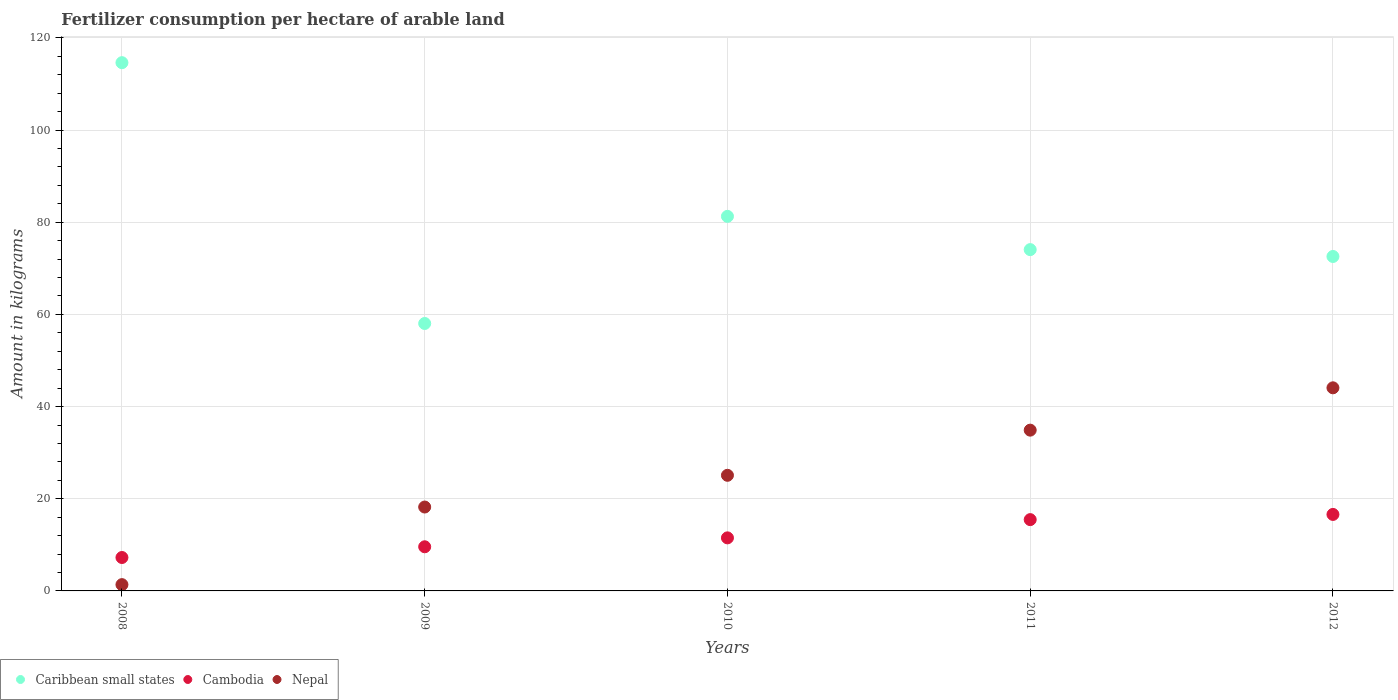What is the amount of fertilizer consumption in Cambodia in 2008?
Keep it short and to the point. 7.25. Across all years, what is the maximum amount of fertilizer consumption in Caribbean small states?
Your answer should be very brief. 114.62. Across all years, what is the minimum amount of fertilizer consumption in Cambodia?
Offer a terse response. 7.25. In which year was the amount of fertilizer consumption in Caribbean small states maximum?
Offer a very short reply. 2008. What is the total amount of fertilizer consumption in Caribbean small states in the graph?
Offer a very short reply. 400.54. What is the difference between the amount of fertilizer consumption in Cambodia in 2009 and that in 2011?
Offer a very short reply. -5.89. What is the difference between the amount of fertilizer consumption in Nepal in 2010 and the amount of fertilizer consumption in Caribbean small states in 2008?
Ensure brevity in your answer.  -89.53. What is the average amount of fertilizer consumption in Nepal per year?
Offer a terse response. 24.72. In the year 2010, what is the difference between the amount of fertilizer consumption in Cambodia and amount of fertilizer consumption in Caribbean small states?
Provide a short and direct response. -69.76. What is the ratio of the amount of fertilizer consumption in Nepal in 2009 to that in 2010?
Keep it short and to the point. 0.73. Is the amount of fertilizer consumption in Cambodia in 2010 less than that in 2012?
Offer a very short reply. Yes. Is the difference between the amount of fertilizer consumption in Cambodia in 2008 and 2009 greater than the difference between the amount of fertilizer consumption in Caribbean small states in 2008 and 2009?
Keep it short and to the point. No. What is the difference between the highest and the second highest amount of fertilizer consumption in Caribbean small states?
Offer a very short reply. 33.34. What is the difference between the highest and the lowest amount of fertilizer consumption in Cambodia?
Offer a very short reply. 9.35. In how many years, is the amount of fertilizer consumption in Caribbean small states greater than the average amount of fertilizer consumption in Caribbean small states taken over all years?
Your answer should be very brief. 2. Is the sum of the amount of fertilizer consumption in Nepal in 2009 and 2010 greater than the maximum amount of fertilizer consumption in Caribbean small states across all years?
Your response must be concise. No. Does the amount of fertilizer consumption in Cambodia monotonically increase over the years?
Keep it short and to the point. Yes. Is the amount of fertilizer consumption in Nepal strictly less than the amount of fertilizer consumption in Cambodia over the years?
Provide a short and direct response. No. How many dotlines are there?
Your answer should be very brief. 3. How many years are there in the graph?
Provide a short and direct response. 5. Are the values on the major ticks of Y-axis written in scientific E-notation?
Keep it short and to the point. No. How are the legend labels stacked?
Offer a very short reply. Horizontal. What is the title of the graph?
Offer a very short reply. Fertilizer consumption per hectare of arable land. What is the label or title of the Y-axis?
Your answer should be very brief. Amount in kilograms. What is the Amount in kilograms in Caribbean small states in 2008?
Keep it short and to the point. 114.62. What is the Amount in kilograms in Cambodia in 2008?
Give a very brief answer. 7.25. What is the Amount in kilograms of Nepal in 2008?
Provide a short and direct response. 1.36. What is the Amount in kilograms of Caribbean small states in 2009?
Your answer should be very brief. 58.03. What is the Amount in kilograms in Cambodia in 2009?
Keep it short and to the point. 9.58. What is the Amount in kilograms in Nepal in 2009?
Provide a succinct answer. 18.2. What is the Amount in kilograms of Caribbean small states in 2010?
Provide a short and direct response. 81.27. What is the Amount in kilograms of Cambodia in 2010?
Make the answer very short. 11.51. What is the Amount in kilograms in Nepal in 2010?
Make the answer very short. 25.09. What is the Amount in kilograms in Caribbean small states in 2011?
Keep it short and to the point. 74.06. What is the Amount in kilograms of Cambodia in 2011?
Your answer should be compact. 15.47. What is the Amount in kilograms of Nepal in 2011?
Ensure brevity in your answer.  34.88. What is the Amount in kilograms in Caribbean small states in 2012?
Keep it short and to the point. 72.57. What is the Amount in kilograms of Cambodia in 2012?
Your response must be concise. 16.6. What is the Amount in kilograms in Nepal in 2012?
Your response must be concise. 44.07. Across all years, what is the maximum Amount in kilograms of Caribbean small states?
Give a very brief answer. 114.62. Across all years, what is the maximum Amount in kilograms in Cambodia?
Keep it short and to the point. 16.6. Across all years, what is the maximum Amount in kilograms in Nepal?
Your response must be concise. 44.07. Across all years, what is the minimum Amount in kilograms of Caribbean small states?
Your answer should be compact. 58.03. Across all years, what is the minimum Amount in kilograms in Cambodia?
Ensure brevity in your answer.  7.25. Across all years, what is the minimum Amount in kilograms of Nepal?
Offer a terse response. 1.36. What is the total Amount in kilograms of Caribbean small states in the graph?
Keep it short and to the point. 400.54. What is the total Amount in kilograms in Cambodia in the graph?
Ensure brevity in your answer.  60.41. What is the total Amount in kilograms of Nepal in the graph?
Make the answer very short. 123.61. What is the difference between the Amount in kilograms in Caribbean small states in 2008 and that in 2009?
Make the answer very short. 56.59. What is the difference between the Amount in kilograms of Cambodia in 2008 and that in 2009?
Make the answer very short. -2.33. What is the difference between the Amount in kilograms in Nepal in 2008 and that in 2009?
Your answer should be very brief. -16.84. What is the difference between the Amount in kilograms in Caribbean small states in 2008 and that in 2010?
Provide a succinct answer. 33.34. What is the difference between the Amount in kilograms of Cambodia in 2008 and that in 2010?
Your answer should be compact. -4.26. What is the difference between the Amount in kilograms in Nepal in 2008 and that in 2010?
Give a very brief answer. -23.72. What is the difference between the Amount in kilograms of Caribbean small states in 2008 and that in 2011?
Provide a succinct answer. 40.56. What is the difference between the Amount in kilograms in Cambodia in 2008 and that in 2011?
Give a very brief answer. -8.22. What is the difference between the Amount in kilograms of Nepal in 2008 and that in 2011?
Your answer should be compact. -33.52. What is the difference between the Amount in kilograms of Caribbean small states in 2008 and that in 2012?
Keep it short and to the point. 42.05. What is the difference between the Amount in kilograms of Cambodia in 2008 and that in 2012?
Offer a terse response. -9.35. What is the difference between the Amount in kilograms of Nepal in 2008 and that in 2012?
Your response must be concise. -42.7. What is the difference between the Amount in kilograms of Caribbean small states in 2009 and that in 2010?
Offer a very short reply. -23.25. What is the difference between the Amount in kilograms in Cambodia in 2009 and that in 2010?
Offer a very short reply. -1.93. What is the difference between the Amount in kilograms in Nepal in 2009 and that in 2010?
Provide a short and direct response. -6.88. What is the difference between the Amount in kilograms of Caribbean small states in 2009 and that in 2011?
Ensure brevity in your answer.  -16.03. What is the difference between the Amount in kilograms in Cambodia in 2009 and that in 2011?
Your response must be concise. -5.89. What is the difference between the Amount in kilograms of Nepal in 2009 and that in 2011?
Your answer should be very brief. -16.68. What is the difference between the Amount in kilograms of Caribbean small states in 2009 and that in 2012?
Your response must be concise. -14.54. What is the difference between the Amount in kilograms of Cambodia in 2009 and that in 2012?
Keep it short and to the point. -7.02. What is the difference between the Amount in kilograms in Nepal in 2009 and that in 2012?
Provide a short and direct response. -25.87. What is the difference between the Amount in kilograms in Caribbean small states in 2010 and that in 2011?
Give a very brief answer. 7.22. What is the difference between the Amount in kilograms in Cambodia in 2010 and that in 2011?
Make the answer very short. -3.96. What is the difference between the Amount in kilograms in Nepal in 2010 and that in 2011?
Your response must be concise. -9.8. What is the difference between the Amount in kilograms of Caribbean small states in 2010 and that in 2012?
Offer a very short reply. 8.71. What is the difference between the Amount in kilograms in Cambodia in 2010 and that in 2012?
Your response must be concise. -5.08. What is the difference between the Amount in kilograms in Nepal in 2010 and that in 2012?
Your answer should be compact. -18.98. What is the difference between the Amount in kilograms in Caribbean small states in 2011 and that in 2012?
Provide a succinct answer. 1.49. What is the difference between the Amount in kilograms of Cambodia in 2011 and that in 2012?
Make the answer very short. -1.13. What is the difference between the Amount in kilograms in Nepal in 2011 and that in 2012?
Ensure brevity in your answer.  -9.19. What is the difference between the Amount in kilograms of Caribbean small states in 2008 and the Amount in kilograms of Cambodia in 2009?
Make the answer very short. 105.04. What is the difference between the Amount in kilograms in Caribbean small states in 2008 and the Amount in kilograms in Nepal in 2009?
Your answer should be very brief. 96.42. What is the difference between the Amount in kilograms of Cambodia in 2008 and the Amount in kilograms of Nepal in 2009?
Your answer should be compact. -10.95. What is the difference between the Amount in kilograms in Caribbean small states in 2008 and the Amount in kilograms in Cambodia in 2010?
Provide a short and direct response. 103.11. What is the difference between the Amount in kilograms of Caribbean small states in 2008 and the Amount in kilograms of Nepal in 2010?
Your answer should be very brief. 89.53. What is the difference between the Amount in kilograms of Cambodia in 2008 and the Amount in kilograms of Nepal in 2010?
Your answer should be very brief. -17.84. What is the difference between the Amount in kilograms in Caribbean small states in 2008 and the Amount in kilograms in Cambodia in 2011?
Offer a very short reply. 99.15. What is the difference between the Amount in kilograms in Caribbean small states in 2008 and the Amount in kilograms in Nepal in 2011?
Ensure brevity in your answer.  79.73. What is the difference between the Amount in kilograms in Cambodia in 2008 and the Amount in kilograms in Nepal in 2011?
Offer a very short reply. -27.63. What is the difference between the Amount in kilograms of Caribbean small states in 2008 and the Amount in kilograms of Cambodia in 2012?
Your response must be concise. 98.02. What is the difference between the Amount in kilograms of Caribbean small states in 2008 and the Amount in kilograms of Nepal in 2012?
Your response must be concise. 70.55. What is the difference between the Amount in kilograms in Cambodia in 2008 and the Amount in kilograms in Nepal in 2012?
Provide a succinct answer. -36.82. What is the difference between the Amount in kilograms of Caribbean small states in 2009 and the Amount in kilograms of Cambodia in 2010?
Make the answer very short. 46.52. What is the difference between the Amount in kilograms of Caribbean small states in 2009 and the Amount in kilograms of Nepal in 2010?
Your answer should be compact. 32.94. What is the difference between the Amount in kilograms in Cambodia in 2009 and the Amount in kilograms in Nepal in 2010?
Ensure brevity in your answer.  -15.51. What is the difference between the Amount in kilograms of Caribbean small states in 2009 and the Amount in kilograms of Cambodia in 2011?
Offer a terse response. 42.56. What is the difference between the Amount in kilograms of Caribbean small states in 2009 and the Amount in kilograms of Nepal in 2011?
Your response must be concise. 23.14. What is the difference between the Amount in kilograms of Cambodia in 2009 and the Amount in kilograms of Nepal in 2011?
Provide a succinct answer. -25.31. What is the difference between the Amount in kilograms of Caribbean small states in 2009 and the Amount in kilograms of Cambodia in 2012?
Ensure brevity in your answer.  41.43. What is the difference between the Amount in kilograms in Caribbean small states in 2009 and the Amount in kilograms in Nepal in 2012?
Keep it short and to the point. 13.96. What is the difference between the Amount in kilograms in Cambodia in 2009 and the Amount in kilograms in Nepal in 2012?
Your answer should be compact. -34.49. What is the difference between the Amount in kilograms of Caribbean small states in 2010 and the Amount in kilograms of Cambodia in 2011?
Your response must be concise. 65.8. What is the difference between the Amount in kilograms of Caribbean small states in 2010 and the Amount in kilograms of Nepal in 2011?
Ensure brevity in your answer.  46.39. What is the difference between the Amount in kilograms in Cambodia in 2010 and the Amount in kilograms in Nepal in 2011?
Your response must be concise. -23.37. What is the difference between the Amount in kilograms in Caribbean small states in 2010 and the Amount in kilograms in Cambodia in 2012?
Ensure brevity in your answer.  64.68. What is the difference between the Amount in kilograms of Caribbean small states in 2010 and the Amount in kilograms of Nepal in 2012?
Make the answer very short. 37.2. What is the difference between the Amount in kilograms in Cambodia in 2010 and the Amount in kilograms in Nepal in 2012?
Keep it short and to the point. -32.56. What is the difference between the Amount in kilograms in Caribbean small states in 2011 and the Amount in kilograms in Cambodia in 2012?
Offer a very short reply. 57.46. What is the difference between the Amount in kilograms in Caribbean small states in 2011 and the Amount in kilograms in Nepal in 2012?
Make the answer very short. 29.99. What is the difference between the Amount in kilograms of Cambodia in 2011 and the Amount in kilograms of Nepal in 2012?
Provide a short and direct response. -28.6. What is the average Amount in kilograms in Caribbean small states per year?
Make the answer very short. 80.11. What is the average Amount in kilograms in Cambodia per year?
Your answer should be compact. 12.08. What is the average Amount in kilograms in Nepal per year?
Provide a short and direct response. 24.72. In the year 2008, what is the difference between the Amount in kilograms of Caribbean small states and Amount in kilograms of Cambodia?
Make the answer very short. 107.37. In the year 2008, what is the difference between the Amount in kilograms of Caribbean small states and Amount in kilograms of Nepal?
Offer a terse response. 113.25. In the year 2008, what is the difference between the Amount in kilograms of Cambodia and Amount in kilograms of Nepal?
Your answer should be compact. 5.88. In the year 2009, what is the difference between the Amount in kilograms of Caribbean small states and Amount in kilograms of Cambodia?
Keep it short and to the point. 48.45. In the year 2009, what is the difference between the Amount in kilograms of Caribbean small states and Amount in kilograms of Nepal?
Your answer should be very brief. 39.82. In the year 2009, what is the difference between the Amount in kilograms in Cambodia and Amount in kilograms in Nepal?
Provide a short and direct response. -8.62. In the year 2010, what is the difference between the Amount in kilograms of Caribbean small states and Amount in kilograms of Cambodia?
Give a very brief answer. 69.76. In the year 2010, what is the difference between the Amount in kilograms of Caribbean small states and Amount in kilograms of Nepal?
Give a very brief answer. 56.19. In the year 2010, what is the difference between the Amount in kilograms of Cambodia and Amount in kilograms of Nepal?
Your answer should be compact. -13.57. In the year 2011, what is the difference between the Amount in kilograms of Caribbean small states and Amount in kilograms of Cambodia?
Make the answer very short. 58.59. In the year 2011, what is the difference between the Amount in kilograms of Caribbean small states and Amount in kilograms of Nepal?
Offer a very short reply. 39.17. In the year 2011, what is the difference between the Amount in kilograms of Cambodia and Amount in kilograms of Nepal?
Provide a short and direct response. -19.41. In the year 2012, what is the difference between the Amount in kilograms of Caribbean small states and Amount in kilograms of Cambodia?
Your answer should be compact. 55.97. In the year 2012, what is the difference between the Amount in kilograms in Caribbean small states and Amount in kilograms in Nepal?
Give a very brief answer. 28.5. In the year 2012, what is the difference between the Amount in kilograms in Cambodia and Amount in kilograms in Nepal?
Offer a very short reply. -27.47. What is the ratio of the Amount in kilograms in Caribbean small states in 2008 to that in 2009?
Offer a very short reply. 1.98. What is the ratio of the Amount in kilograms of Cambodia in 2008 to that in 2009?
Ensure brevity in your answer.  0.76. What is the ratio of the Amount in kilograms of Nepal in 2008 to that in 2009?
Offer a very short reply. 0.07. What is the ratio of the Amount in kilograms of Caribbean small states in 2008 to that in 2010?
Your answer should be very brief. 1.41. What is the ratio of the Amount in kilograms in Cambodia in 2008 to that in 2010?
Offer a very short reply. 0.63. What is the ratio of the Amount in kilograms in Nepal in 2008 to that in 2010?
Your answer should be very brief. 0.05. What is the ratio of the Amount in kilograms in Caribbean small states in 2008 to that in 2011?
Give a very brief answer. 1.55. What is the ratio of the Amount in kilograms of Cambodia in 2008 to that in 2011?
Offer a terse response. 0.47. What is the ratio of the Amount in kilograms in Nepal in 2008 to that in 2011?
Your response must be concise. 0.04. What is the ratio of the Amount in kilograms in Caribbean small states in 2008 to that in 2012?
Ensure brevity in your answer.  1.58. What is the ratio of the Amount in kilograms in Cambodia in 2008 to that in 2012?
Make the answer very short. 0.44. What is the ratio of the Amount in kilograms of Nepal in 2008 to that in 2012?
Give a very brief answer. 0.03. What is the ratio of the Amount in kilograms in Caribbean small states in 2009 to that in 2010?
Give a very brief answer. 0.71. What is the ratio of the Amount in kilograms of Cambodia in 2009 to that in 2010?
Give a very brief answer. 0.83. What is the ratio of the Amount in kilograms of Nepal in 2009 to that in 2010?
Your answer should be very brief. 0.73. What is the ratio of the Amount in kilograms in Caribbean small states in 2009 to that in 2011?
Offer a terse response. 0.78. What is the ratio of the Amount in kilograms of Cambodia in 2009 to that in 2011?
Your answer should be very brief. 0.62. What is the ratio of the Amount in kilograms of Nepal in 2009 to that in 2011?
Your answer should be compact. 0.52. What is the ratio of the Amount in kilograms in Caribbean small states in 2009 to that in 2012?
Ensure brevity in your answer.  0.8. What is the ratio of the Amount in kilograms of Cambodia in 2009 to that in 2012?
Ensure brevity in your answer.  0.58. What is the ratio of the Amount in kilograms of Nepal in 2009 to that in 2012?
Offer a very short reply. 0.41. What is the ratio of the Amount in kilograms of Caribbean small states in 2010 to that in 2011?
Keep it short and to the point. 1.1. What is the ratio of the Amount in kilograms in Cambodia in 2010 to that in 2011?
Provide a short and direct response. 0.74. What is the ratio of the Amount in kilograms in Nepal in 2010 to that in 2011?
Keep it short and to the point. 0.72. What is the ratio of the Amount in kilograms of Caribbean small states in 2010 to that in 2012?
Give a very brief answer. 1.12. What is the ratio of the Amount in kilograms of Cambodia in 2010 to that in 2012?
Offer a terse response. 0.69. What is the ratio of the Amount in kilograms of Nepal in 2010 to that in 2012?
Your response must be concise. 0.57. What is the ratio of the Amount in kilograms in Caribbean small states in 2011 to that in 2012?
Your response must be concise. 1.02. What is the ratio of the Amount in kilograms of Cambodia in 2011 to that in 2012?
Provide a short and direct response. 0.93. What is the ratio of the Amount in kilograms in Nepal in 2011 to that in 2012?
Give a very brief answer. 0.79. What is the difference between the highest and the second highest Amount in kilograms in Caribbean small states?
Provide a short and direct response. 33.34. What is the difference between the highest and the second highest Amount in kilograms of Cambodia?
Offer a terse response. 1.13. What is the difference between the highest and the second highest Amount in kilograms in Nepal?
Your response must be concise. 9.19. What is the difference between the highest and the lowest Amount in kilograms in Caribbean small states?
Offer a very short reply. 56.59. What is the difference between the highest and the lowest Amount in kilograms of Cambodia?
Offer a very short reply. 9.35. What is the difference between the highest and the lowest Amount in kilograms of Nepal?
Your response must be concise. 42.7. 